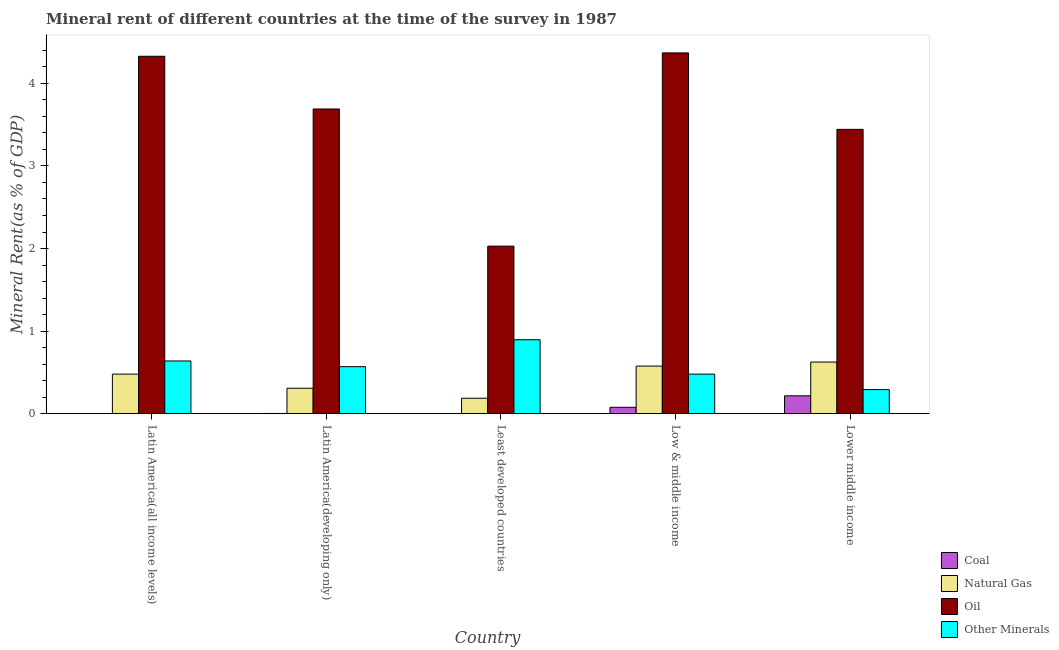What is the label of the 2nd group of bars from the left?
Provide a succinct answer. Latin America(developing only). In how many cases, is the number of bars for a given country not equal to the number of legend labels?
Keep it short and to the point. 0. What is the coal rent in Latin America(all income levels)?
Ensure brevity in your answer.  0. Across all countries, what is the maximum  rent of other minerals?
Keep it short and to the point. 0.9. Across all countries, what is the minimum natural gas rent?
Your answer should be compact. 0.19. In which country was the coal rent maximum?
Your answer should be very brief. Lower middle income. In which country was the coal rent minimum?
Offer a very short reply. Least developed countries. What is the total  rent of other minerals in the graph?
Provide a short and direct response. 2.88. What is the difference between the natural gas rent in Low & middle income and that in Lower middle income?
Provide a short and direct response. -0.05. What is the difference between the  rent of other minerals in Latin America(developing only) and the oil rent in Low & middle income?
Offer a terse response. -3.8. What is the average oil rent per country?
Offer a very short reply. 3.57. What is the difference between the oil rent and natural gas rent in Low & middle income?
Your answer should be compact. 3.79. In how many countries, is the natural gas rent greater than 0.2 %?
Provide a short and direct response. 4. What is the ratio of the natural gas rent in Latin America(developing only) to that in Low & middle income?
Ensure brevity in your answer.  0.54. Is the oil rent in Latin America(developing only) less than that in Low & middle income?
Keep it short and to the point. Yes. Is the difference between the  rent of other minerals in Latin America(developing only) and Least developed countries greater than the difference between the natural gas rent in Latin America(developing only) and Least developed countries?
Offer a terse response. No. What is the difference between the highest and the second highest natural gas rent?
Your answer should be very brief. 0.05. What is the difference between the highest and the lowest coal rent?
Your answer should be compact. 0.22. Is the sum of the coal rent in Least developed countries and Low & middle income greater than the maximum  rent of other minerals across all countries?
Ensure brevity in your answer.  No. What does the 1st bar from the left in Latin America(all income levels) represents?
Your answer should be compact. Coal. What does the 4th bar from the right in Low & middle income represents?
Offer a very short reply. Coal. How many bars are there?
Ensure brevity in your answer.  20. What is the difference between two consecutive major ticks on the Y-axis?
Ensure brevity in your answer.  1. Are the values on the major ticks of Y-axis written in scientific E-notation?
Your answer should be very brief. No. Does the graph contain any zero values?
Offer a terse response. No. How are the legend labels stacked?
Offer a terse response. Vertical. What is the title of the graph?
Offer a very short reply. Mineral rent of different countries at the time of the survey in 1987. What is the label or title of the Y-axis?
Keep it short and to the point. Mineral Rent(as % of GDP). What is the Mineral Rent(as % of GDP) in Coal in Latin America(all income levels)?
Offer a terse response. 0. What is the Mineral Rent(as % of GDP) of Natural Gas in Latin America(all income levels)?
Provide a succinct answer. 0.48. What is the Mineral Rent(as % of GDP) of Oil in Latin America(all income levels)?
Keep it short and to the point. 4.33. What is the Mineral Rent(as % of GDP) of Other Minerals in Latin America(all income levels)?
Your response must be concise. 0.64. What is the Mineral Rent(as % of GDP) in Coal in Latin America(developing only)?
Your answer should be compact. 0. What is the Mineral Rent(as % of GDP) of Natural Gas in Latin America(developing only)?
Make the answer very short. 0.31. What is the Mineral Rent(as % of GDP) of Oil in Latin America(developing only)?
Your answer should be very brief. 3.69. What is the Mineral Rent(as % of GDP) of Other Minerals in Latin America(developing only)?
Make the answer very short. 0.57. What is the Mineral Rent(as % of GDP) in Coal in Least developed countries?
Offer a terse response. 5.84697420507121e-6. What is the Mineral Rent(as % of GDP) in Natural Gas in Least developed countries?
Offer a very short reply. 0.19. What is the Mineral Rent(as % of GDP) in Oil in Least developed countries?
Your response must be concise. 2.03. What is the Mineral Rent(as % of GDP) of Other Minerals in Least developed countries?
Ensure brevity in your answer.  0.9. What is the Mineral Rent(as % of GDP) in Coal in Low & middle income?
Provide a short and direct response. 0.08. What is the Mineral Rent(as % of GDP) of Natural Gas in Low & middle income?
Offer a very short reply. 0.58. What is the Mineral Rent(as % of GDP) in Oil in Low & middle income?
Your answer should be very brief. 4.37. What is the Mineral Rent(as % of GDP) in Other Minerals in Low & middle income?
Offer a terse response. 0.48. What is the Mineral Rent(as % of GDP) in Coal in Lower middle income?
Your response must be concise. 0.22. What is the Mineral Rent(as % of GDP) in Natural Gas in Lower middle income?
Offer a terse response. 0.63. What is the Mineral Rent(as % of GDP) in Oil in Lower middle income?
Give a very brief answer. 3.44. What is the Mineral Rent(as % of GDP) of Other Minerals in Lower middle income?
Keep it short and to the point. 0.29. Across all countries, what is the maximum Mineral Rent(as % of GDP) of Coal?
Your response must be concise. 0.22. Across all countries, what is the maximum Mineral Rent(as % of GDP) of Natural Gas?
Make the answer very short. 0.63. Across all countries, what is the maximum Mineral Rent(as % of GDP) of Oil?
Your answer should be compact. 4.37. Across all countries, what is the maximum Mineral Rent(as % of GDP) of Other Minerals?
Your response must be concise. 0.9. Across all countries, what is the minimum Mineral Rent(as % of GDP) of Coal?
Provide a succinct answer. 5.84697420507121e-6. Across all countries, what is the minimum Mineral Rent(as % of GDP) in Natural Gas?
Keep it short and to the point. 0.19. Across all countries, what is the minimum Mineral Rent(as % of GDP) of Oil?
Give a very brief answer. 2.03. Across all countries, what is the minimum Mineral Rent(as % of GDP) in Other Minerals?
Your response must be concise. 0.29. What is the total Mineral Rent(as % of GDP) of Coal in the graph?
Provide a short and direct response. 0.3. What is the total Mineral Rent(as % of GDP) of Natural Gas in the graph?
Your response must be concise. 2.18. What is the total Mineral Rent(as % of GDP) of Oil in the graph?
Your answer should be very brief. 17.86. What is the total Mineral Rent(as % of GDP) of Other Minerals in the graph?
Give a very brief answer. 2.88. What is the difference between the Mineral Rent(as % of GDP) of Coal in Latin America(all income levels) and that in Latin America(developing only)?
Provide a succinct answer. -0. What is the difference between the Mineral Rent(as % of GDP) in Natural Gas in Latin America(all income levels) and that in Latin America(developing only)?
Give a very brief answer. 0.17. What is the difference between the Mineral Rent(as % of GDP) of Oil in Latin America(all income levels) and that in Latin America(developing only)?
Make the answer very short. 0.64. What is the difference between the Mineral Rent(as % of GDP) of Other Minerals in Latin America(all income levels) and that in Latin America(developing only)?
Provide a short and direct response. 0.07. What is the difference between the Mineral Rent(as % of GDP) of Coal in Latin America(all income levels) and that in Least developed countries?
Provide a succinct answer. 0. What is the difference between the Mineral Rent(as % of GDP) of Natural Gas in Latin America(all income levels) and that in Least developed countries?
Your answer should be compact. 0.29. What is the difference between the Mineral Rent(as % of GDP) in Oil in Latin America(all income levels) and that in Least developed countries?
Keep it short and to the point. 2.3. What is the difference between the Mineral Rent(as % of GDP) in Other Minerals in Latin America(all income levels) and that in Least developed countries?
Your answer should be very brief. -0.26. What is the difference between the Mineral Rent(as % of GDP) of Coal in Latin America(all income levels) and that in Low & middle income?
Your response must be concise. -0.08. What is the difference between the Mineral Rent(as % of GDP) in Natural Gas in Latin America(all income levels) and that in Low & middle income?
Provide a succinct answer. -0.1. What is the difference between the Mineral Rent(as % of GDP) in Oil in Latin America(all income levels) and that in Low & middle income?
Ensure brevity in your answer.  -0.04. What is the difference between the Mineral Rent(as % of GDP) in Other Minerals in Latin America(all income levels) and that in Low & middle income?
Provide a succinct answer. 0.16. What is the difference between the Mineral Rent(as % of GDP) in Coal in Latin America(all income levels) and that in Lower middle income?
Your answer should be very brief. -0.21. What is the difference between the Mineral Rent(as % of GDP) in Natural Gas in Latin America(all income levels) and that in Lower middle income?
Your answer should be compact. -0.15. What is the difference between the Mineral Rent(as % of GDP) of Oil in Latin America(all income levels) and that in Lower middle income?
Keep it short and to the point. 0.88. What is the difference between the Mineral Rent(as % of GDP) of Other Minerals in Latin America(all income levels) and that in Lower middle income?
Your answer should be compact. 0.35. What is the difference between the Mineral Rent(as % of GDP) in Coal in Latin America(developing only) and that in Least developed countries?
Ensure brevity in your answer.  0. What is the difference between the Mineral Rent(as % of GDP) of Natural Gas in Latin America(developing only) and that in Least developed countries?
Your response must be concise. 0.12. What is the difference between the Mineral Rent(as % of GDP) in Oil in Latin America(developing only) and that in Least developed countries?
Make the answer very short. 1.66. What is the difference between the Mineral Rent(as % of GDP) of Other Minerals in Latin America(developing only) and that in Least developed countries?
Provide a short and direct response. -0.33. What is the difference between the Mineral Rent(as % of GDP) in Coal in Latin America(developing only) and that in Low & middle income?
Give a very brief answer. -0.07. What is the difference between the Mineral Rent(as % of GDP) in Natural Gas in Latin America(developing only) and that in Low & middle income?
Offer a very short reply. -0.27. What is the difference between the Mineral Rent(as % of GDP) in Oil in Latin America(developing only) and that in Low & middle income?
Your response must be concise. -0.68. What is the difference between the Mineral Rent(as % of GDP) of Other Minerals in Latin America(developing only) and that in Low & middle income?
Provide a short and direct response. 0.09. What is the difference between the Mineral Rent(as % of GDP) of Coal in Latin America(developing only) and that in Lower middle income?
Ensure brevity in your answer.  -0.21. What is the difference between the Mineral Rent(as % of GDP) in Natural Gas in Latin America(developing only) and that in Lower middle income?
Make the answer very short. -0.32. What is the difference between the Mineral Rent(as % of GDP) in Oil in Latin America(developing only) and that in Lower middle income?
Keep it short and to the point. 0.25. What is the difference between the Mineral Rent(as % of GDP) in Other Minerals in Latin America(developing only) and that in Lower middle income?
Your response must be concise. 0.28. What is the difference between the Mineral Rent(as % of GDP) in Coal in Least developed countries and that in Low & middle income?
Keep it short and to the point. -0.08. What is the difference between the Mineral Rent(as % of GDP) of Natural Gas in Least developed countries and that in Low & middle income?
Give a very brief answer. -0.39. What is the difference between the Mineral Rent(as % of GDP) in Oil in Least developed countries and that in Low & middle income?
Make the answer very short. -2.34. What is the difference between the Mineral Rent(as % of GDP) of Other Minerals in Least developed countries and that in Low & middle income?
Your answer should be compact. 0.42. What is the difference between the Mineral Rent(as % of GDP) of Coal in Least developed countries and that in Lower middle income?
Offer a terse response. -0.22. What is the difference between the Mineral Rent(as % of GDP) in Natural Gas in Least developed countries and that in Lower middle income?
Provide a short and direct response. -0.44. What is the difference between the Mineral Rent(as % of GDP) of Oil in Least developed countries and that in Lower middle income?
Provide a succinct answer. -1.41. What is the difference between the Mineral Rent(as % of GDP) in Other Minerals in Least developed countries and that in Lower middle income?
Ensure brevity in your answer.  0.6. What is the difference between the Mineral Rent(as % of GDP) in Coal in Low & middle income and that in Lower middle income?
Your answer should be compact. -0.14. What is the difference between the Mineral Rent(as % of GDP) in Natural Gas in Low & middle income and that in Lower middle income?
Offer a terse response. -0.05. What is the difference between the Mineral Rent(as % of GDP) in Oil in Low & middle income and that in Lower middle income?
Offer a terse response. 0.93. What is the difference between the Mineral Rent(as % of GDP) of Other Minerals in Low & middle income and that in Lower middle income?
Provide a succinct answer. 0.19. What is the difference between the Mineral Rent(as % of GDP) of Coal in Latin America(all income levels) and the Mineral Rent(as % of GDP) of Natural Gas in Latin America(developing only)?
Make the answer very short. -0.31. What is the difference between the Mineral Rent(as % of GDP) of Coal in Latin America(all income levels) and the Mineral Rent(as % of GDP) of Oil in Latin America(developing only)?
Your answer should be very brief. -3.69. What is the difference between the Mineral Rent(as % of GDP) in Coal in Latin America(all income levels) and the Mineral Rent(as % of GDP) in Other Minerals in Latin America(developing only)?
Your answer should be compact. -0.57. What is the difference between the Mineral Rent(as % of GDP) of Natural Gas in Latin America(all income levels) and the Mineral Rent(as % of GDP) of Oil in Latin America(developing only)?
Give a very brief answer. -3.21. What is the difference between the Mineral Rent(as % of GDP) of Natural Gas in Latin America(all income levels) and the Mineral Rent(as % of GDP) of Other Minerals in Latin America(developing only)?
Keep it short and to the point. -0.09. What is the difference between the Mineral Rent(as % of GDP) in Oil in Latin America(all income levels) and the Mineral Rent(as % of GDP) in Other Minerals in Latin America(developing only)?
Your answer should be very brief. 3.76. What is the difference between the Mineral Rent(as % of GDP) of Coal in Latin America(all income levels) and the Mineral Rent(as % of GDP) of Natural Gas in Least developed countries?
Provide a short and direct response. -0.19. What is the difference between the Mineral Rent(as % of GDP) in Coal in Latin America(all income levels) and the Mineral Rent(as % of GDP) in Oil in Least developed countries?
Provide a succinct answer. -2.03. What is the difference between the Mineral Rent(as % of GDP) in Coal in Latin America(all income levels) and the Mineral Rent(as % of GDP) in Other Minerals in Least developed countries?
Provide a short and direct response. -0.89. What is the difference between the Mineral Rent(as % of GDP) in Natural Gas in Latin America(all income levels) and the Mineral Rent(as % of GDP) in Oil in Least developed countries?
Offer a terse response. -1.55. What is the difference between the Mineral Rent(as % of GDP) of Natural Gas in Latin America(all income levels) and the Mineral Rent(as % of GDP) of Other Minerals in Least developed countries?
Your response must be concise. -0.42. What is the difference between the Mineral Rent(as % of GDP) of Oil in Latin America(all income levels) and the Mineral Rent(as % of GDP) of Other Minerals in Least developed countries?
Offer a very short reply. 3.43. What is the difference between the Mineral Rent(as % of GDP) of Coal in Latin America(all income levels) and the Mineral Rent(as % of GDP) of Natural Gas in Low & middle income?
Give a very brief answer. -0.57. What is the difference between the Mineral Rent(as % of GDP) of Coal in Latin America(all income levels) and the Mineral Rent(as % of GDP) of Oil in Low & middle income?
Your response must be concise. -4.37. What is the difference between the Mineral Rent(as % of GDP) of Coal in Latin America(all income levels) and the Mineral Rent(as % of GDP) of Other Minerals in Low & middle income?
Your response must be concise. -0.48. What is the difference between the Mineral Rent(as % of GDP) in Natural Gas in Latin America(all income levels) and the Mineral Rent(as % of GDP) in Oil in Low & middle income?
Your response must be concise. -3.89. What is the difference between the Mineral Rent(as % of GDP) of Oil in Latin America(all income levels) and the Mineral Rent(as % of GDP) of Other Minerals in Low & middle income?
Provide a short and direct response. 3.85. What is the difference between the Mineral Rent(as % of GDP) of Coal in Latin America(all income levels) and the Mineral Rent(as % of GDP) of Natural Gas in Lower middle income?
Provide a succinct answer. -0.62. What is the difference between the Mineral Rent(as % of GDP) in Coal in Latin America(all income levels) and the Mineral Rent(as % of GDP) in Oil in Lower middle income?
Make the answer very short. -3.44. What is the difference between the Mineral Rent(as % of GDP) of Coal in Latin America(all income levels) and the Mineral Rent(as % of GDP) of Other Minerals in Lower middle income?
Your answer should be compact. -0.29. What is the difference between the Mineral Rent(as % of GDP) of Natural Gas in Latin America(all income levels) and the Mineral Rent(as % of GDP) of Oil in Lower middle income?
Make the answer very short. -2.96. What is the difference between the Mineral Rent(as % of GDP) of Natural Gas in Latin America(all income levels) and the Mineral Rent(as % of GDP) of Other Minerals in Lower middle income?
Offer a very short reply. 0.19. What is the difference between the Mineral Rent(as % of GDP) of Oil in Latin America(all income levels) and the Mineral Rent(as % of GDP) of Other Minerals in Lower middle income?
Give a very brief answer. 4.04. What is the difference between the Mineral Rent(as % of GDP) in Coal in Latin America(developing only) and the Mineral Rent(as % of GDP) in Natural Gas in Least developed countries?
Make the answer very short. -0.18. What is the difference between the Mineral Rent(as % of GDP) in Coal in Latin America(developing only) and the Mineral Rent(as % of GDP) in Oil in Least developed countries?
Your answer should be compact. -2.03. What is the difference between the Mineral Rent(as % of GDP) of Coal in Latin America(developing only) and the Mineral Rent(as % of GDP) of Other Minerals in Least developed countries?
Offer a terse response. -0.89. What is the difference between the Mineral Rent(as % of GDP) in Natural Gas in Latin America(developing only) and the Mineral Rent(as % of GDP) in Oil in Least developed countries?
Offer a terse response. -1.72. What is the difference between the Mineral Rent(as % of GDP) of Natural Gas in Latin America(developing only) and the Mineral Rent(as % of GDP) of Other Minerals in Least developed countries?
Offer a terse response. -0.59. What is the difference between the Mineral Rent(as % of GDP) of Oil in Latin America(developing only) and the Mineral Rent(as % of GDP) of Other Minerals in Least developed countries?
Keep it short and to the point. 2.79. What is the difference between the Mineral Rent(as % of GDP) in Coal in Latin America(developing only) and the Mineral Rent(as % of GDP) in Natural Gas in Low & middle income?
Your answer should be very brief. -0.57. What is the difference between the Mineral Rent(as % of GDP) in Coal in Latin America(developing only) and the Mineral Rent(as % of GDP) in Oil in Low & middle income?
Give a very brief answer. -4.36. What is the difference between the Mineral Rent(as % of GDP) in Coal in Latin America(developing only) and the Mineral Rent(as % of GDP) in Other Minerals in Low & middle income?
Make the answer very short. -0.48. What is the difference between the Mineral Rent(as % of GDP) in Natural Gas in Latin America(developing only) and the Mineral Rent(as % of GDP) in Oil in Low & middle income?
Provide a short and direct response. -4.06. What is the difference between the Mineral Rent(as % of GDP) of Natural Gas in Latin America(developing only) and the Mineral Rent(as % of GDP) of Other Minerals in Low & middle income?
Offer a very short reply. -0.17. What is the difference between the Mineral Rent(as % of GDP) of Oil in Latin America(developing only) and the Mineral Rent(as % of GDP) of Other Minerals in Low & middle income?
Offer a very short reply. 3.21. What is the difference between the Mineral Rent(as % of GDP) in Coal in Latin America(developing only) and the Mineral Rent(as % of GDP) in Natural Gas in Lower middle income?
Make the answer very short. -0.62. What is the difference between the Mineral Rent(as % of GDP) in Coal in Latin America(developing only) and the Mineral Rent(as % of GDP) in Oil in Lower middle income?
Your answer should be compact. -3.44. What is the difference between the Mineral Rent(as % of GDP) in Coal in Latin America(developing only) and the Mineral Rent(as % of GDP) in Other Minerals in Lower middle income?
Provide a succinct answer. -0.29. What is the difference between the Mineral Rent(as % of GDP) of Natural Gas in Latin America(developing only) and the Mineral Rent(as % of GDP) of Oil in Lower middle income?
Provide a succinct answer. -3.13. What is the difference between the Mineral Rent(as % of GDP) of Natural Gas in Latin America(developing only) and the Mineral Rent(as % of GDP) of Other Minerals in Lower middle income?
Your answer should be very brief. 0.02. What is the difference between the Mineral Rent(as % of GDP) in Oil in Latin America(developing only) and the Mineral Rent(as % of GDP) in Other Minerals in Lower middle income?
Provide a succinct answer. 3.4. What is the difference between the Mineral Rent(as % of GDP) in Coal in Least developed countries and the Mineral Rent(as % of GDP) in Natural Gas in Low & middle income?
Your answer should be compact. -0.58. What is the difference between the Mineral Rent(as % of GDP) of Coal in Least developed countries and the Mineral Rent(as % of GDP) of Oil in Low & middle income?
Provide a short and direct response. -4.37. What is the difference between the Mineral Rent(as % of GDP) in Coal in Least developed countries and the Mineral Rent(as % of GDP) in Other Minerals in Low & middle income?
Give a very brief answer. -0.48. What is the difference between the Mineral Rent(as % of GDP) in Natural Gas in Least developed countries and the Mineral Rent(as % of GDP) in Oil in Low & middle income?
Your response must be concise. -4.18. What is the difference between the Mineral Rent(as % of GDP) in Natural Gas in Least developed countries and the Mineral Rent(as % of GDP) in Other Minerals in Low & middle income?
Keep it short and to the point. -0.29. What is the difference between the Mineral Rent(as % of GDP) of Oil in Least developed countries and the Mineral Rent(as % of GDP) of Other Minerals in Low & middle income?
Give a very brief answer. 1.55. What is the difference between the Mineral Rent(as % of GDP) in Coal in Least developed countries and the Mineral Rent(as % of GDP) in Natural Gas in Lower middle income?
Ensure brevity in your answer.  -0.63. What is the difference between the Mineral Rent(as % of GDP) in Coal in Least developed countries and the Mineral Rent(as % of GDP) in Oil in Lower middle income?
Your answer should be compact. -3.44. What is the difference between the Mineral Rent(as % of GDP) in Coal in Least developed countries and the Mineral Rent(as % of GDP) in Other Minerals in Lower middle income?
Your answer should be compact. -0.29. What is the difference between the Mineral Rent(as % of GDP) of Natural Gas in Least developed countries and the Mineral Rent(as % of GDP) of Oil in Lower middle income?
Offer a terse response. -3.25. What is the difference between the Mineral Rent(as % of GDP) of Natural Gas in Least developed countries and the Mineral Rent(as % of GDP) of Other Minerals in Lower middle income?
Your answer should be very brief. -0.1. What is the difference between the Mineral Rent(as % of GDP) of Oil in Least developed countries and the Mineral Rent(as % of GDP) of Other Minerals in Lower middle income?
Offer a terse response. 1.74. What is the difference between the Mineral Rent(as % of GDP) of Coal in Low & middle income and the Mineral Rent(as % of GDP) of Natural Gas in Lower middle income?
Provide a succinct answer. -0.55. What is the difference between the Mineral Rent(as % of GDP) of Coal in Low & middle income and the Mineral Rent(as % of GDP) of Oil in Lower middle income?
Give a very brief answer. -3.36. What is the difference between the Mineral Rent(as % of GDP) in Coal in Low & middle income and the Mineral Rent(as % of GDP) in Other Minerals in Lower middle income?
Your response must be concise. -0.21. What is the difference between the Mineral Rent(as % of GDP) in Natural Gas in Low & middle income and the Mineral Rent(as % of GDP) in Oil in Lower middle income?
Your answer should be very brief. -2.87. What is the difference between the Mineral Rent(as % of GDP) of Natural Gas in Low & middle income and the Mineral Rent(as % of GDP) of Other Minerals in Lower middle income?
Offer a terse response. 0.28. What is the difference between the Mineral Rent(as % of GDP) of Oil in Low & middle income and the Mineral Rent(as % of GDP) of Other Minerals in Lower middle income?
Offer a terse response. 4.08. What is the average Mineral Rent(as % of GDP) of Coal per country?
Provide a short and direct response. 0.06. What is the average Mineral Rent(as % of GDP) in Natural Gas per country?
Your answer should be very brief. 0.44. What is the average Mineral Rent(as % of GDP) of Oil per country?
Your response must be concise. 3.57. What is the average Mineral Rent(as % of GDP) of Other Minerals per country?
Give a very brief answer. 0.58. What is the difference between the Mineral Rent(as % of GDP) of Coal and Mineral Rent(as % of GDP) of Natural Gas in Latin America(all income levels)?
Your answer should be very brief. -0.48. What is the difference between the Mineral Rent(as % of GDP) in Coal and Mineral Rent(as % of GDP) in Oil in Latin America(all income levels)?
Provide a short and direct response. -4.33. What is the difference between the Mineral Rent(as % of GDP) of Coal and Mineral Rent(as % of GDP) of Other Minerals in Latin America(all income levels)?
Give a very brief answer. -0.64. What is the difference between the Mineral Rent(as % of GDP) of Natural Gas and Mineral Rent(as % of GDP) of Oil in Latin America(all income levels)?
Offer a terse response. -3.85. What is the difference between the Mineral Rent(as % of GDP) of Natural Gas and Mineral Rent(as % of GDP) of Other Minerals in Latin America(all income levels)?
Your response must be concise. -0.16. What is the difference between the Mineral Rent(as % of GDP) in Oil and Mineral Rent(as % of GDP) in Other Minerals in Latin America(all income levels)?
Make the answer very short. 3.69. What is the difference between the Mineral Rent(as % of GDP) in Coal and Mineral Rent(as % of GDP) in Natural Gas in Latin America(developing only)?
Offer a very short reply. -0.31. What is the difference between the Mineral Rent(as % of GDP) in Coal and Mineral Rent(as % of GDP) in Oil in Latin America(developing only)?
Your response must be concise. -3.69. What is the difference between the Mineral Rent(as % of GDP) in Coal and Mineral Rent(as % of GDP) in Other Minerals in Latin America(developing only)?
Keep it short and to the point. -0.57. What is the difference between the Mineral Rent(as % of GDP) in Natural Gas and Mineral Rent(as % of GDP) in Oil in Latin America(developing only)?
Your answer should be compact. -3.38. What is the difference between the Mineral Rent(as % of GDP) in Natural Gas and Mineral Rent(as % of GDP) in Other Minerals in Latin America(developing only)?
Provide a succinct answer. -0.26. What is the difference between the Mineral Rent(as % of GDP) of Oil and Mineral Rent(as % of GDP) of Other Minerals in Latin America(developing only)?
Provide a succinct answer. 3.12. What is the difference between the Mineral Rent(as % of GDP) in Coal and Mineral Rent(as % of GDP) in Natural Gas in Least developed countries?
Your answer should be compact. -0.19. What is the difference between the Mineral Rent(as % of GDP) in Coal and Mineral Rent(as % of GDP) in Oil in Least developed countries?
Your answer should be very brief. -2.03. What is the difference between the Mineral Rent(as % of GDP) of Coal and Mineral Rent(as % of GDP) of Other Minerals in Least developed countries?
Offer a very short reply. -0.9. What is the difference between the Mineral Rent(as % of GDP) of Natural Gas and Mineral Rent(as % of GDP) of Oil in Least developed countries?
Keep it short and to the point. -1.84. What is the difference between the Mineral Rent(as % of GDP) of Natural Gas and Mineral Rent(as % of GDP) of Other Minerals in Least developed countries?
Provide a succinct answer. -0.71. What is the difference between the Mineral Rent(as % of GDP) in Oil and Mineral Rent(as % of GDP) in Other Minerals in Least developed countries?
Make the answer very short. 1.13. What is the difference between the Mineral Rent(as % of GDP) of Coal and Mineral Rent(as % of GDP) of Natural Gas in Low & middle income?
Your answer should be compact. -0.5. What is the difference between the Mineral Rent(as % of GDP) in Coal and Mineral Rent(as % of GDP) in Oil in Low & middle income?
Your response must be concise. -4.29. What is the difference between the Mineral Rent(as % of GDP) of Coal and Mineral Rent(as % of GDP) of Other Minerals in Low & middle income?
Provide a short and direct response. -0.4. What is the difference between the Mineral Rent(as % of GDP) in Natural Gas and Mineral Rent(as % of GDP) in Oil in Low & middle income?
Offer a terse response. -3.79. What is the difference between the Mineral Rent(as % of GDP) of Natural Gas and Mineral Rent(as % of GDP) of Other Minerals in Low & middle income?
Your answer should be compact. 0.1. What is the difference between the Mineral Rent(as % of GDP) of Oil and Mineral Rent(as % of GDP) of Other Minerals in Low & middle income?
Keep it short and to the point. 3.89. What is the difference between the Mineral Rent(as % of GDP) of Coal and Mineral Rent(as % of GDP) of Natural Gas in Lower middle income?
Offer a very short reply. -0.41. What is the difference between the Mineral Rent(as % of GDP) in Coal and Mineral Rent(as % of GDP) in Oil in Lower middle income?
Give a very brief answer. -3.23. What is the difference between the Mineral Rent(as % of GDP) of Coal and Mineral Rent(as % of GDP) of Other Minerals in Lower middle income?
Keep it short and to the point. -0.08. What is the difference between the Mineral Rent(as % of GDP) of Natural Gas and Mineral Rent(as % of GDP) of Oil in Lower middle income?
Your answer should be very brief. -2.82. What is the difference between the Mineral Rent(as % of GDP) of Natural Gas and Mineral Rent(as % of GDP) of Other Minerals in Lower middle income?
Give a very brief answer. 0.33. What is the difference between the Mineral Rent(as % of GDP) in Oil and Mineral Rent(as % of GDP) in Other Minerals in Lower middle income?
Your answer should be very brief. 3.15. What is the ratio of the Mineral Rent(as % of GDP) of Coal in Latin America(all income levels) to that in Latin America(developing only)?
Provide a succinct answer. 0.73. What is the ratio of the Mineral Rent(as % of GDP) of Natural Gas in Latin America(all income levels) to that in Latin America(developing only)?
Give a very brief answer. 1.55. What is the ratio of the Mineral Rent(as % of GDP) in Oil in Latin America(all income levels) to that in Latin America(developing only)?
Provide a succinct answer. 1.17. What is the ratio of the Mineral Rent(as % of GDP) of Other Minerals in Latin America(all income levels) to that in Latin America(developing only)?
Offer a very short reply. 1.12. What is the ratio of the Mineral Rent(as % of GDP) of Coal in Latin America(all income levels) to that in Least developed countries?
Your answer should be compact. 425.18. What is the ratio of the Mineral Rent(as % of GDP) of Natural Gas in Latin America(all income levels) to that in Least developed countries?
Give a very brief answer. 2.56. What is the ratio of the Mineral Rent(as % of GDP) in Oil in Latin America(all income levels) to that in Least developed countries?
Your answer should be very brief. 2.13. What is the ratio of the Mineral Rent(as % of GDP) in Other Minerals in Latin America(all income levels) to that in Least developed countries?
Your answer should be compact. 0.71. What is the ratio of the Mineral Rent(as % of GDP) in Coal in Latin America(all income levels) to that in Low & middle income?
Your answer should be very brief. 0.03. What is the ratio of the Mineral Rent(as % of GDP) of Natural Gas in Latin America(all income levels) to that in Low & middle income?
Offer a very short reply. 0.83. What is the ratio of the Mineral Rent(as % of GDP) in Oil in Latin America(all income levels) to that in Low & middle income?
Provide a short and direct response. 0.99. What is the ratio of the Mineral Rent(as % of GDP) in Other Minerals in Latin America(all income levels) to that in Low & middle income?
Provide a succinct answer. 1.33. What is the ratio of the Mineral Rent(as % of GDP) in Coal in Latin America(all income levels) to that in Lower middle income?
Keep it short and to the point. 0.01. What is the ratio of the Mineral Rent(as % of GDP) of Natural Gas in Latin America(all income levels) to that in Lower middle income?
Keep it short and to the point. 0.77. What is the ratio of the Mineral Rent(as % of GDP) of Oil in Latin America(all income levels) to that in Lower middle income?
Your response must be concise. 1.26. What is the ratio of the Mineral Rent(as % of GDP) of Other Minerals in Latin America(all income levels) to that in Lower middle income?
Make the answer very short. 2.19. What is the ratio of the Mineral Rent(as % of GDP) of Coal in Latin America(developing only) to that in Least developed countries?
Offer a very short reply. 585.97. What is the ratio of the Mineral Rent(as % of GDP) in Natural Gas in Latin America(developing only) to that in Least developed countries?
Your answer should be very brief. 1.64. What is the ratio of the Mineral Rent(as % of GDP) of Oil in Latin America(developing only) to that in Least developed countries?
Keep it short and to the point. 1.82. What is the ratio of the Mineral Rent(as % of GDP) in Other Minerals in Latin America(developing only) to that in Least developed countries?
Give a very brief answer. 0.64. What is the ratio of the Mineral Rent(as % of GDP) of Coal in Latin America(developing only) to that in Low & middle income?
Your answer should be compact. 0.04. What is the ratio of the Mineral Rent(as % of GDP) in Natural Gas in Latin America(developing only) to that in Low & middle income?
Your answer should be very brief. 0.54. What is the ratio of the Mineral Rent(as % of GDP) in Oil in Latin America(developing only) to that in Low & middle income?
Offer a terse response. 0.84. What is the ratio of the Mineral Rent(as % of GDP) in Other Minerals in Latin America(developing only) to that in Low & middle income?
Ensure brevity in your answer.  1.19. What is the ratio of the Mineral Rent(as % of GDP) in Coal in Latin America(developing only) to that in Lower middle income?
Offer a very short reply. 0.02. What is the ratio of the Mineral Rent(as % of GDP) in Natural Gas in Latin America(developing only) to that in Lower middle income?
Make the answer very short. 0.49. What is the ratio of the Mineral Rent(as % of GDP) of Oil in Latin America(developing only) to that in Lower middle income?
Keep it short and to the point. 1.07. What is the ratio of the Mineral Rent(as % of GDP) of Other Minerals in Latin America(developing only) to that in Lower middle income?
Keep it short and to the point. 1.95. What is the ratio of the Mineral Rent(as % of GDP) of Natural Gas in Least developed countries to that in Low & middle income?
Make the answer very short. 0.33. What is the ratio of the Mineral Rent(as % of GDP) of Oil in Least developed countries to that in Low & middle income?
Make the answer very short. 0.46. What is the ratio of the Mineral Rent(as % of GDP) of Other Minerals in Least developed countries to that in Low & middle income?
Your answer should be compact. 1.87. What is the ratio of the Mineral Rent(as % of GDP) in Coal in Least developed countries to that in Lower middle income?
Keep it short and to the point. 0. What is the ratio of the Mineral Rent(as % of GDP) in Natural Gas in Least developed countries to that in Lower middle income?
Give a very brief answer. 0.3. What is the ratio of the Mineral Rent(as % of GDP) in Oil in Least developed countries to that in Lower middle income?
Your answer should be very brief. 0.59. What is the ratio of the Mineral Rent(as % of GDP) of Other Minerals in Least developed countries to that in Lower middle income?
Ensure brevity in your answer.  3.07. What is the ratio of the Mineral Rent(as % of GDP) in Coal in Low & middle income to that in Lower middle income?
Keep it short and to the point. 0.36. What is the ratio of the Mineral Rent(as % of GDP) of Natural Gas in Low & middle income to that in Lower middle income?
Offer a terse response. 0.92. What is the ratio of the Mineral Rent(as % of GDP) of Oil in Low & middle income to that in Lower middle income?
Give a very brief answer. 1.27. What is the ratio of the Mineral Rent(as % of GDP) of Other Minerals in Low & middle income to that in Lower middle income?
Give a very brief answer. 1.64. What is the difference between the highest and the second highest Mineral Rent(as % of GDP) of Coal?
Your answer should be very brief. 0.14. What is the difference between the highest and the second highest Mineral Rent(as % of GDP) in Natural Gas?
Provide a succinct answer. 0.05. What is the difference between the highest and the second highest Mineral Rent(as % of GDP) in Oil?
Offer a terse response. 0.04. What is the difference between the highest and the second highest Mineral Rent(as % of GDP) of Other Minerals?
Your answer should be very brief. 0.26. What is the difference between the highest and the lowest Mineral Rent(as % of GDP) in Coal?
Your answer should be compact. 0.22. What is the difference between the highest and the lowest Mineral Rent(as % of GDP) in Natural Gas?
Your answer should be very brief. 0.44. What is the difference between the highest and the lowest Mineral Rent(as % of GDP) in Oil?
Offer a terse response. 2.34. What is the difference between the highest and the lowest Mineral Rent(as % of GDP) in Other Minerals?
Provide a short and direct response. 0.6. 